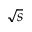Convert formula to latex. <formula><loc_0><loc_0><loc_500><loc_500>\sqrt { s }</formula> 